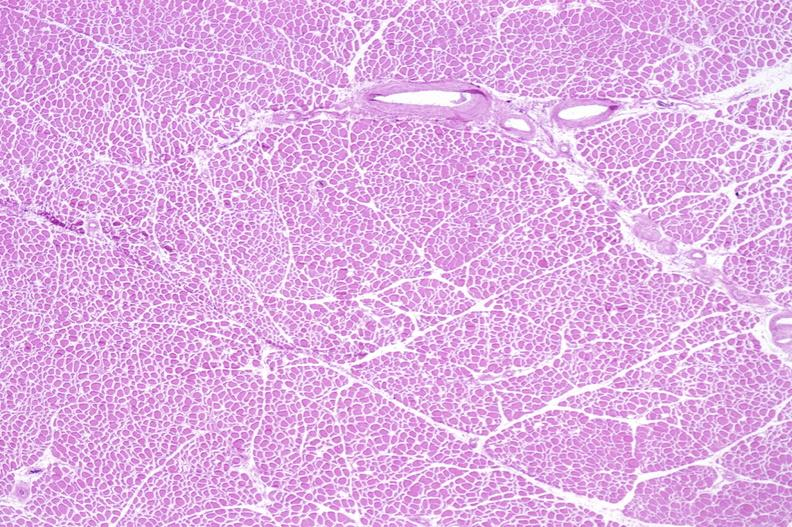s normal newborn present?
Answer the question using a single word or phrase. No 